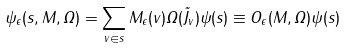<formula> <loc_0><loc_0><loc_500><loc_500>\psi _ { \epsilon } ( s , M , \Omega ) = \sum _ { v \in s } M _ { \epsilon } ( v ) \Omega ( \vec { J } _ { v } ) \psi ( s ) \equiv O _ { \epsilon } ( M , \Omega ) \psi ( s ) \,</formula> 